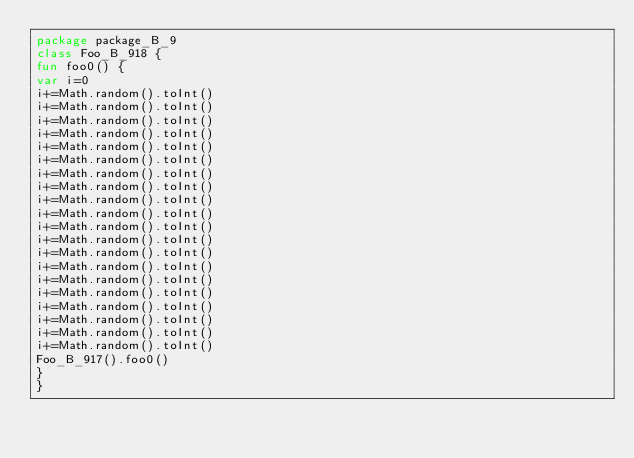Convert code to text. <code><loc_0><loc_0><loc_500><loc_500><_Kotlin_>package package_B_9
class Foo_B_918 {
fun foo0() {
var i=0
i+=Math.random().toInt()
i+=Math.random().toInt()
i+=Math.random().toInt()
i+=Math.random().toInt()
i+=Math.random().toInt()
i+=Math.random().toInt()
i+=Math.random().toInt()
i+=Math.random().toInt()
i+=Math.random().toInt()
i+=Math.random().toInt()
i+=Math.random().toInt()
i+=Math.random().toInt()
i+=Math.random().toInt()
i+=Math.random().toInt()
i+=Math.random().toInt()
i+=Math.random().toInt()
i+=Math.random().toInt()
i+=Math.random().toInt()
i+=Math.random().toInt()
i+=Math.random().toInt()
Foo_B_917().foo0()
}
}</code> 